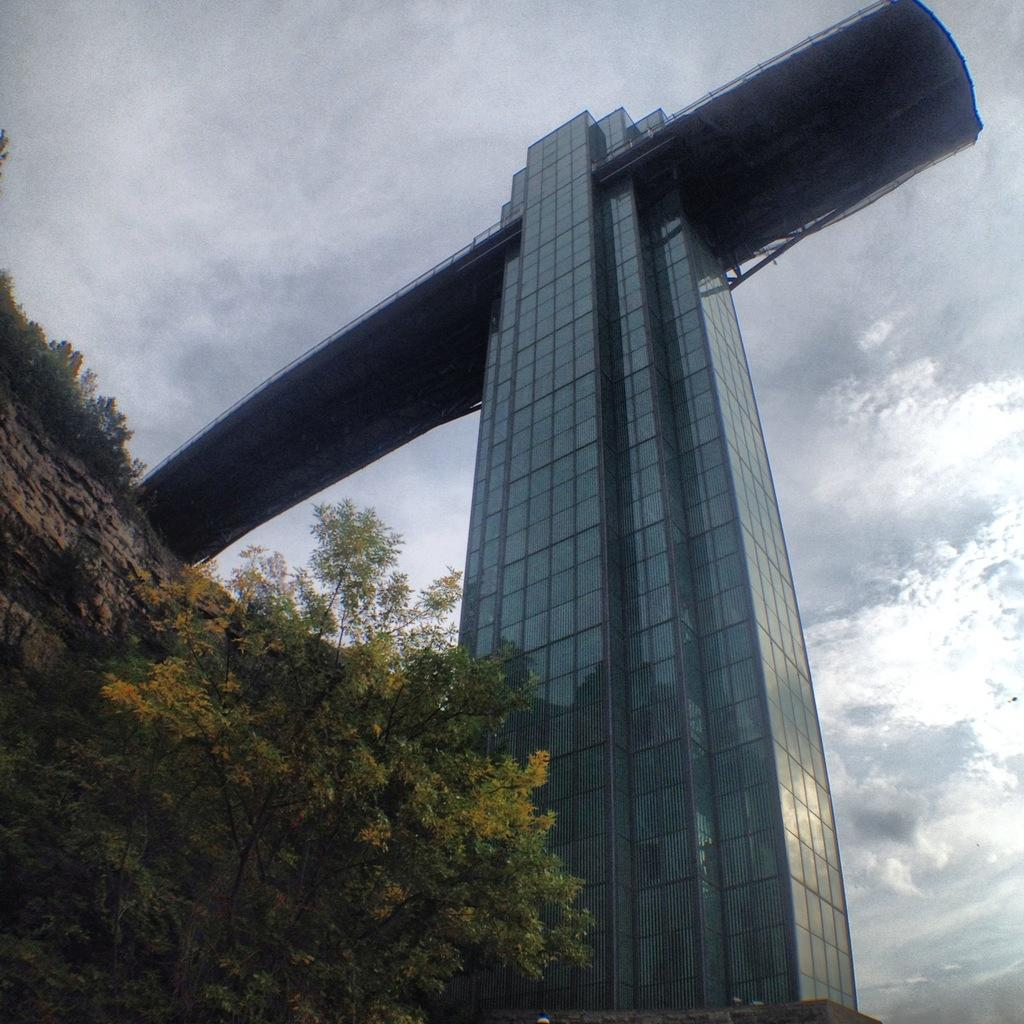What type of structure is present in the image? There is a building in the image. What other natural elements can be seen in the image? There are trees in the image. What is visible in the background of the image? The sky is visible in the background of the image. What can be observed in the sky in the background of the image? There are clouds in the sky in the background of the image. What type of love can be seen emanating from the building in the image? There is no indication of love in the image; it features a building, trees, and a sky with clouds. What type of magic is being performed by the rays of sunlight in the image? There is no mention of magic or rays of sunlight in the image. 